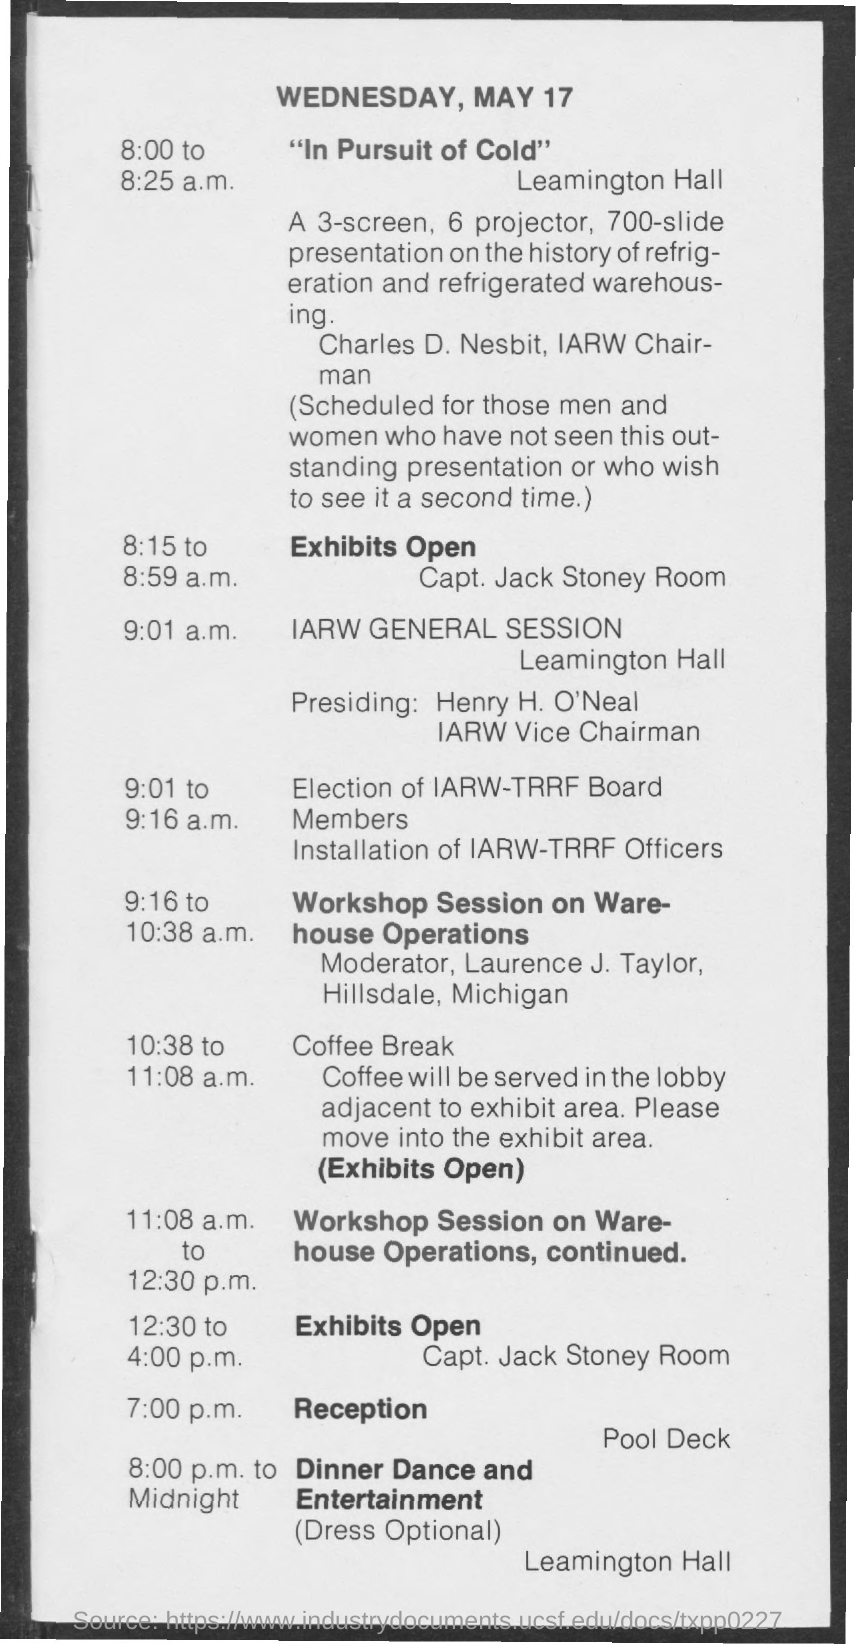What is the date mentioned in the given page ?
Provide a short and direct response. May 17. 